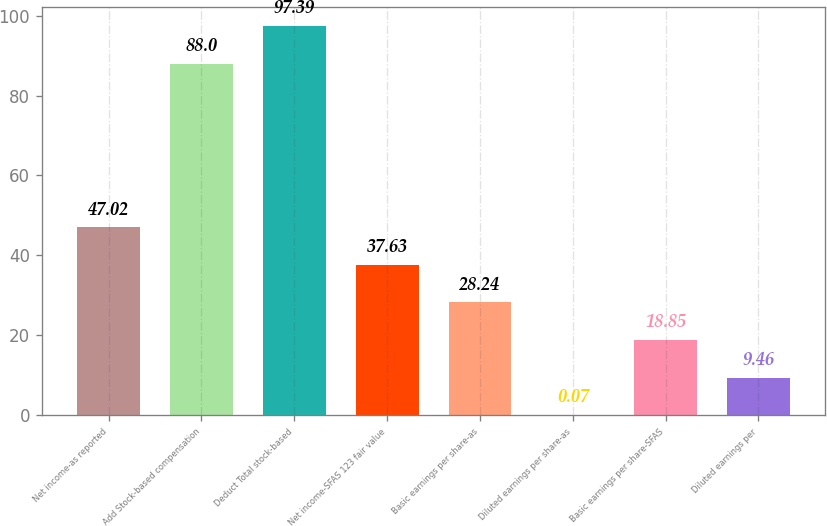Convert chart. <chart><loc_0><loc_0><loc_500><loc_500><bar_chart><fcel>Net income-as reported<fcel>Add Stock-based compensation<fcel>Deduct Total stock-based<fcel>Net income-SFAS 123 fair value<fcel>Basic earnings per share-as<fcel>Diluted earnings per share-as<fcel>Basic earnings per share-SFAS<fcel>Diluted earnings per<nl><fcel>47.02<fcel>88<fcel>97.39<fcel>37.63<fcel>28.24<fcel>0.07<fcel>18.85<fcel>9.46<nl></chart> 